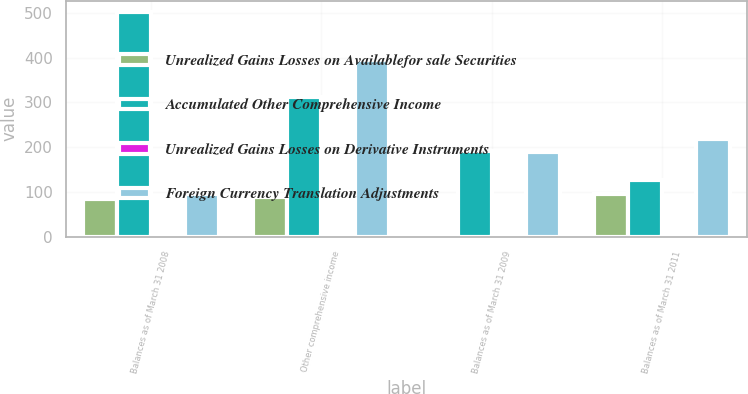Convert chart to OTSL. <chart><loc_0><loc_0><loc_500><loc_500><stacked_bar_chart><ecel><fcel>Balances as of March 31 2008<fcel>Other comprehensive income<fcel>Balances as of March 31 2009<fcel>Balances as of March 31 2011<nl><fcel>Unrealized Gains Losses on Availablefor sale Securities<fcel>85<fcel>88<fcel>3<fcel>95<nl><fcel>Accumulated Other Comprehensive Income<fcel>502<fcel>311<fcel>191<fcel>126<nl><fcel>Unrealized Gains Losses on Derivative Instruments<fcel>3<fcel>4<fcel>1<fcel>2<nl><fcel>Foreign Currency Translation Adjustments<fcel>95<fcel>395<fcel>189<fcel>219<nl></chart> 